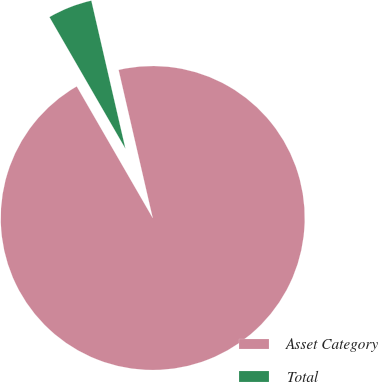Convert chart. <chart><loc_0><loc_0><loc_500><loc_500><pie_chart><fcel>Asset Category<fcel>Total<nl><fcel>95.27%<fcel>4.73%<nl></chart> 